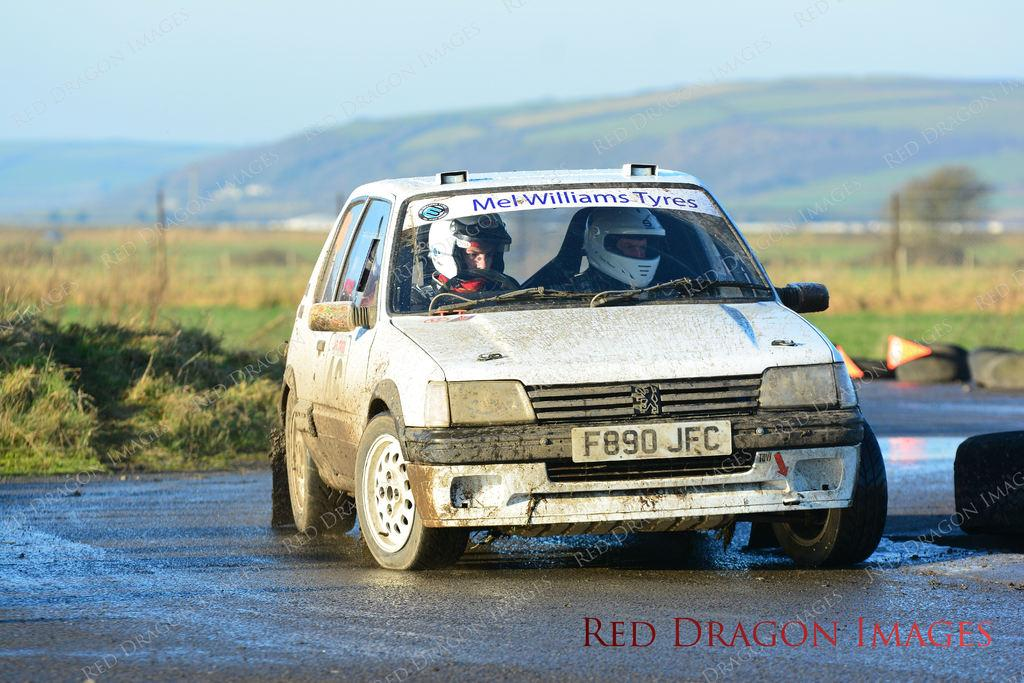What is the main subject of the image? The main subject of the image is a car on the road. Who or what is inside the car? There are two men in the car. What type of vegetation can be seen in the image? Grass is visible in the image. What part of the natural environment is visible in the image? The sky is visible in the image. What can be seen in the background of the image? Tires are present in the background of the image. What type of division is taking place in the image? There is no division taking place in the image; it features a car on the road with two men inside. What color is the sweater worn by the doll in the image? There is no doll present in the image, and therefore no sweater to describe. 